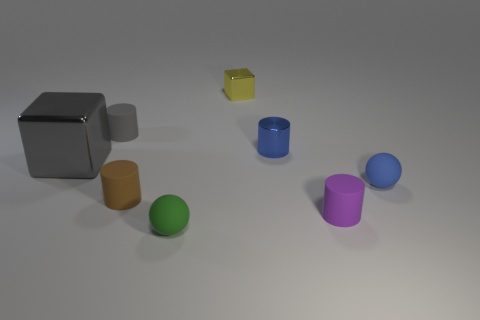Are there any small matte things that have the same color as the big object?
Provide a succinct answer. Yes. Is the number of brown objects on the left side of the gray block less than the number of large blocks that are on the right side of the purple rubber cylinder?
Your answer should be very brief. No. What is the shape of the metal object that is left of the brown object?
Make the answer very short. Cube. Are the big gray thing and the brown thing made of the same material?
Offer a terse response. No. There is a small gray thing that is the same shape as the purple matte object; what is its material?
Offer a very short reply. Rubber. Are there fewer small purple rubber cylinders right of the big object than big metallic cubes?
Provide a succinct answer. No. How many brown matte objects are to the right of the big cube?
Make the answer very short. 1. There is a small blue object that is behind the large object; is it the same shape as the brown matte object to the left of the purple rubber cylinder?
Your answer should be compact. Yes. What shape is the tiny rubber thing that is both left of the tiny metallic block and in front of the tiny brown cylinder?
Your response must be concise. Sphere. What size is the cube that is the same material as the tiny yellow thing?
Offer a terse response. Large. 